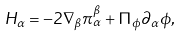<formula> <loc_0><loc_0><loc_500><loc_500>H _ { \alpha } = - 2 \nabla _ { \beta } \pi _ { \alpha } ^ { \beta } + \Pi _ { \phi } \partial _ { \alpha } \phi ,</formula> 